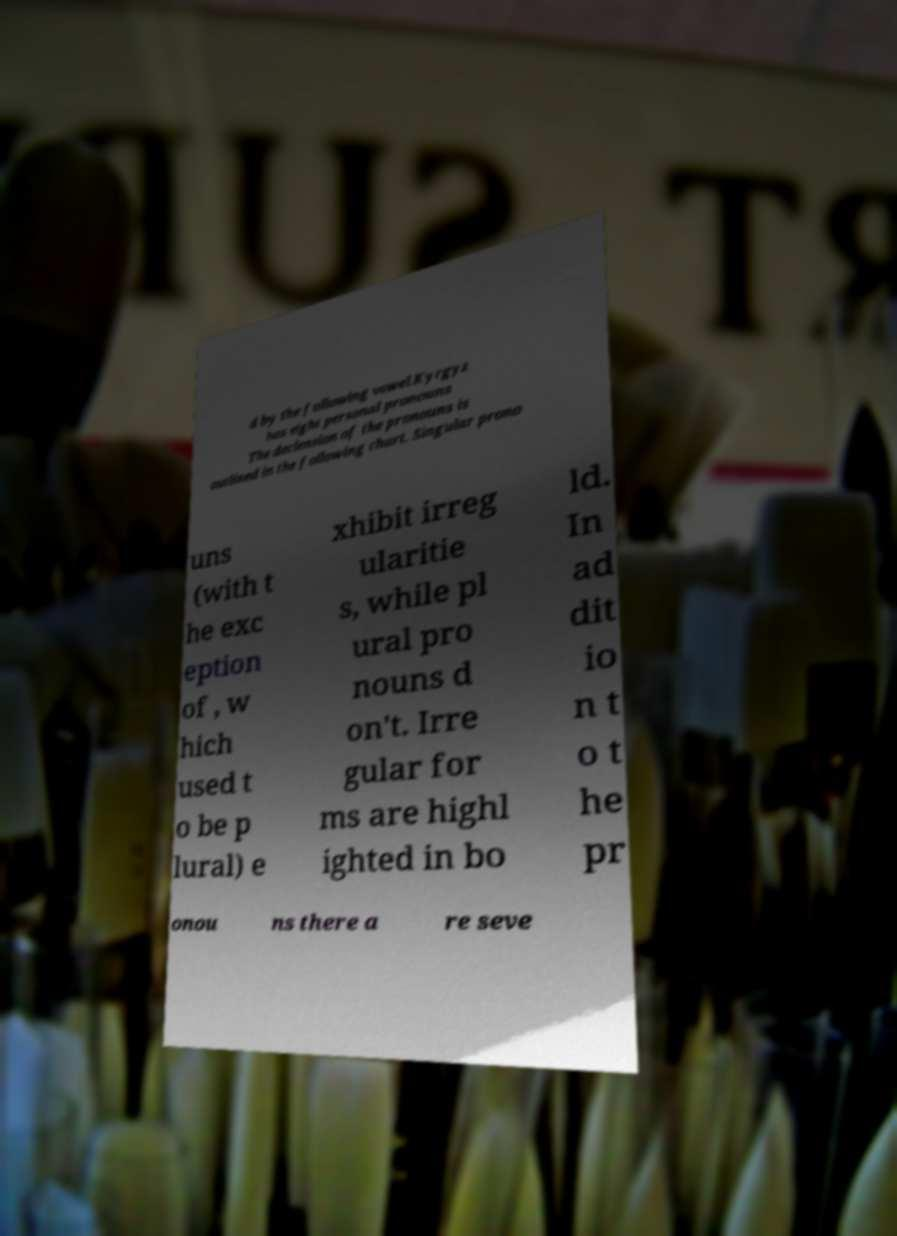I need the written content from this picture converted into text. Can you do that? d by the following vowel.Kyrgyz has eight personal pronouns The declension of the pronouns is outlined in the following chart. Singular prono uns (with t he exc eption of , w hich used t o be p lural) e xhibit irreg ularitie s, while pl ural pro nouns d on't. Irre gular for ms are highl ighted in bo ld. In ad dit io n t o t he pr onou ns there a re seve 